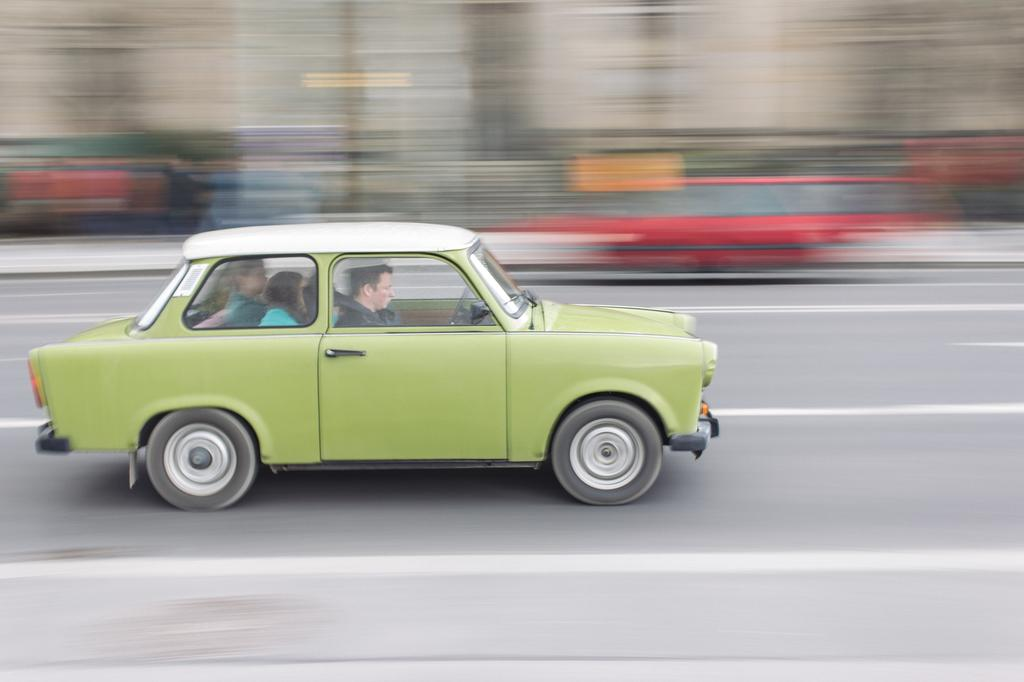How many people are in the image? There are three people in the image. What are the people doing in the image? The people are riding a green color car. What can be seen at the bottom of the image? There is a road visible at the bottom of the image. What is the condition of the background in the image? The background of the image is blurred. What type of scientific error can be seen in the image? There is no scientific error present in the image. What type of fruit is being transported in the car in the image? There is no fruit visible in the image; the people are riding a green color car, but no fruit is mentioned or depicted. 